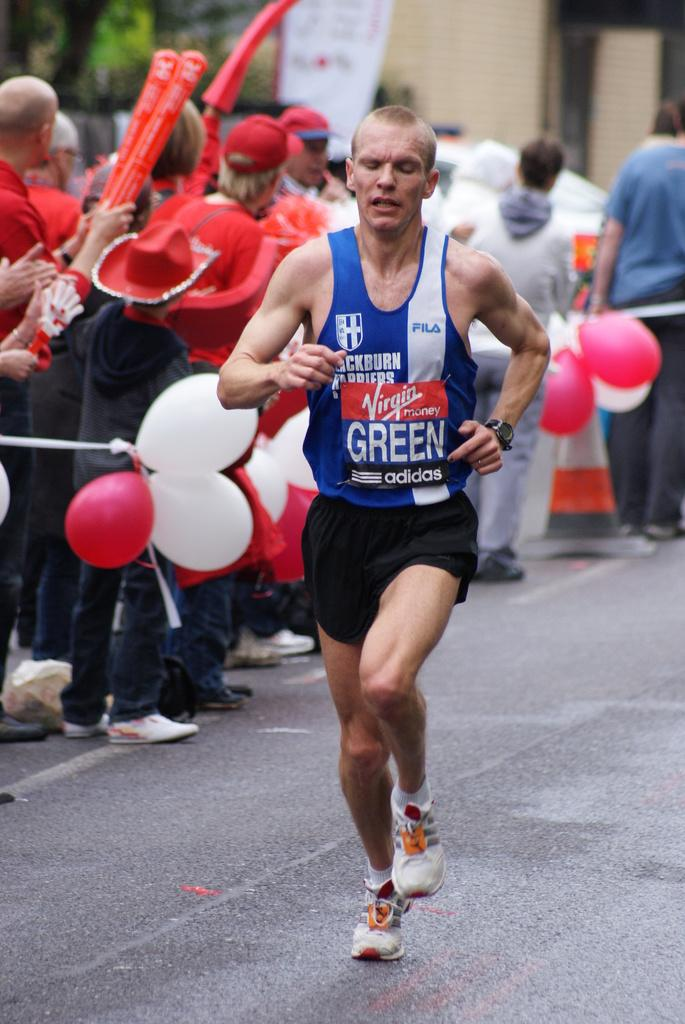<image>
Present a compact description of the photo's key features. A man running down the street wearing a blue and white tank top with the name green on his mid section. 